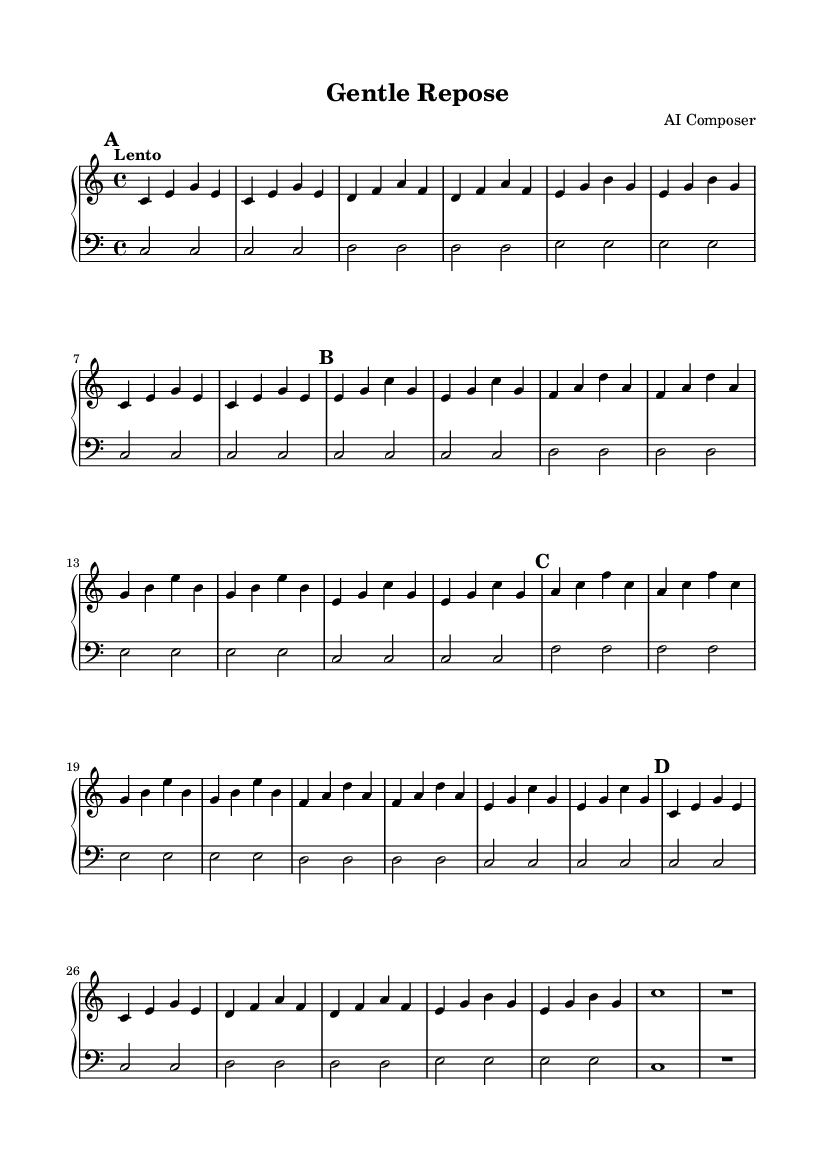What is the key signature of this music? The key signature is indicated at the beginning of the music, and it shows C major, which has no sharps or flats.
Answer: C major What is the time signature of this piece? The time signature is indicated at the beginning of the score and is set to 4/4, meaning there are four beats in each measure.
Answer: 4/4 What is the tempo marking for this composition? The tempo marking appears in the score, stating "Lento," which indicates a slow tempo. The beats per minute are marked at 60.
Answer: Lento How many sections are there in this piece? By analyzing the structure of the music, we see there are four distinct sections labeled A, A', B, and A''.
Answer: 4 Which notes comprise the opening chord in Section A? The opening chord consists of notes C, E, and G, played simultaneously as the first measure of Section A.
Answer: C, E, G What is the dynamic marking for the upper staff? In the music score for the upper staff, there is a dynamic marking indicating the notes should be played up, which signifies a gentle and flowing touch.
Answer: Up Which sections repeat within the composition? The sections A and A' each appear multiple times in the score, specifically in the repeated patterns defined by the music structure.
Answer: A, A' 